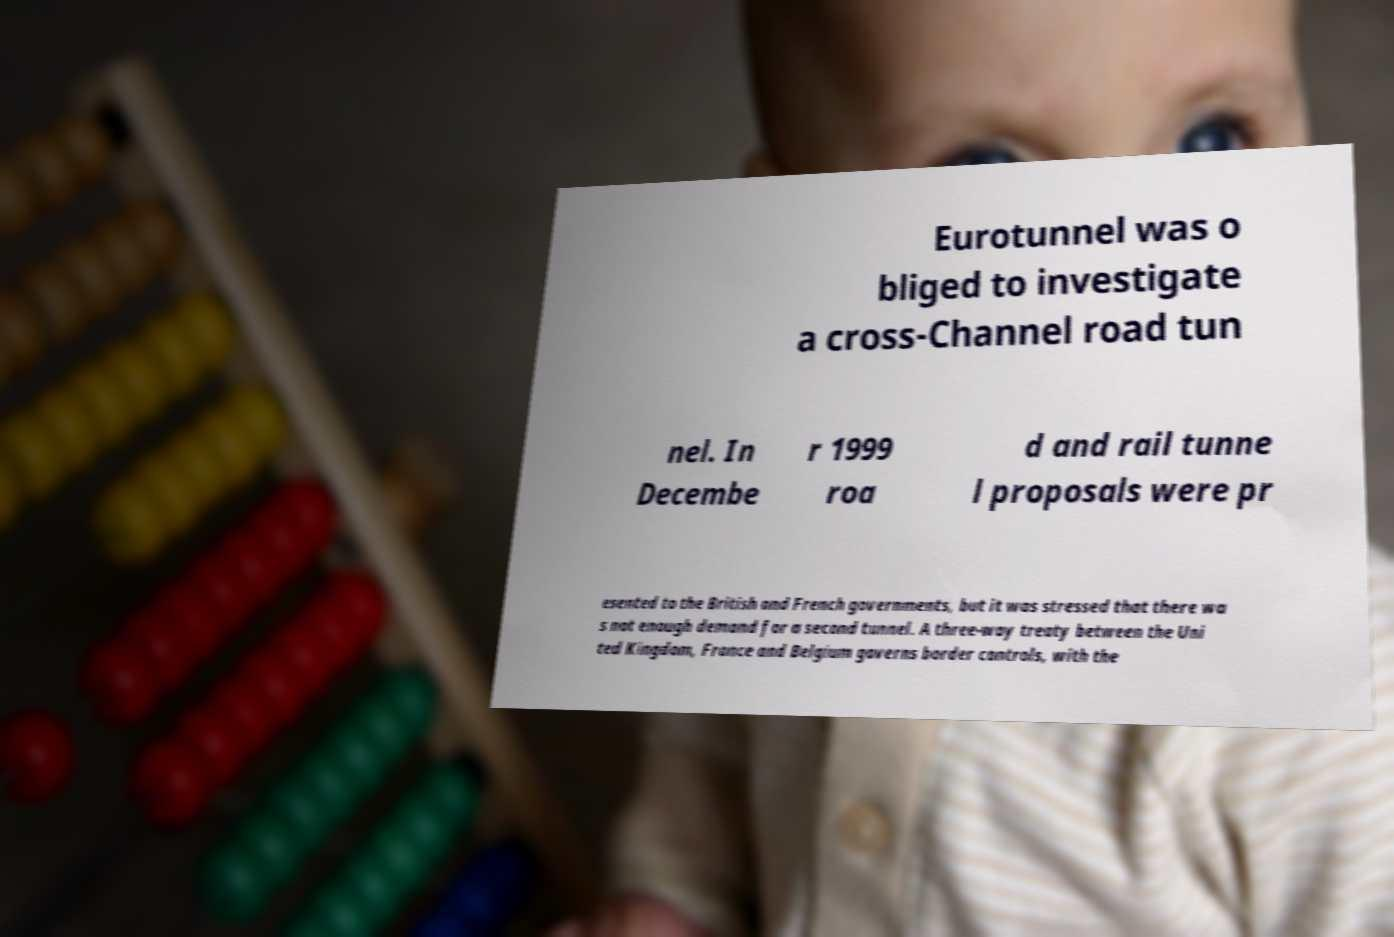Please read and relay the text visible in this image. What does it say? Eurotunnel was o bliged to investigate a cross-Channel road tun nel. In Decembe r 1999 roa d and rail tunne l proposals were pr esented to the British and French governments, but it was stressed that there wa s not enough demand for a second tunnel. A three-way treaty between the Uni ted Kingdom, France and Belgium governs border controls, with the 